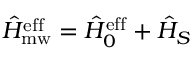<formula> <loc_0><loc_0><loc_500><loc_500>\hat { H } _ { m w } ^ { e f f } = \hat { H } _ { 0 } ^ { e f f } + \hat { H } _ { S }</formula> 